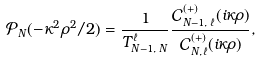<formula> <loc_0><loc_0><loc_500><loc_500>\mathcal { P } _ { N } ( - \kappa ^ { 2 } \rho ^ { 2 } / 2 ) = \frac { 1 } { T _ { N - 1 , \, N } ^ { \ell } } \frac { \mathcal { C } _ { N - 1 , \, \ell } ^ { ( + ) } ( i \kappa \rho ) } { \mathcal { C } _ { N , \, \ell } ^ { ( + ) } ( i \kappa \rho ) } ,</formula> 